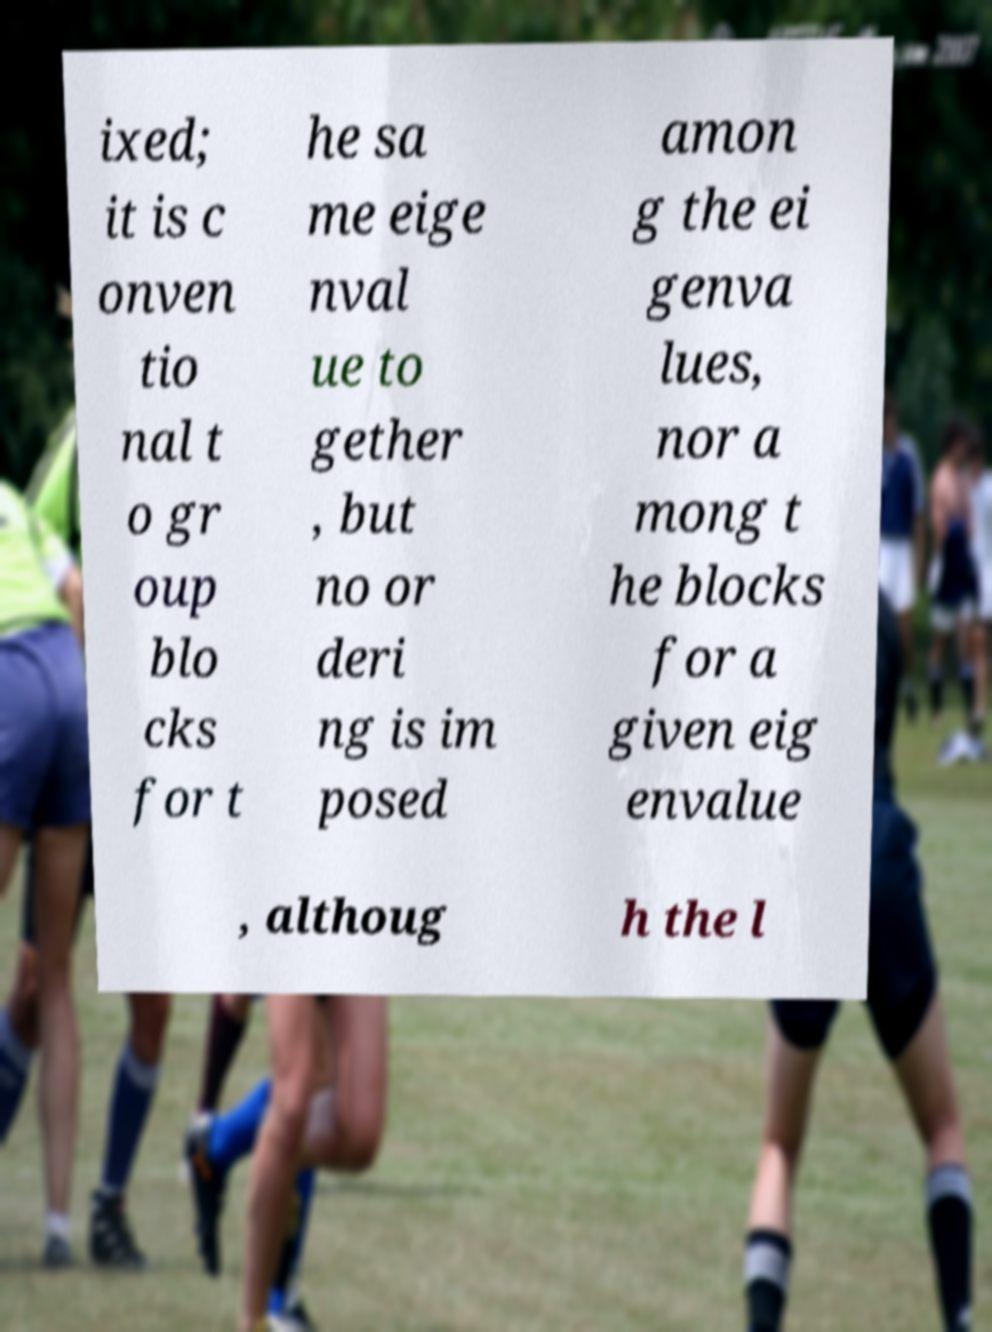Can you accurately transcribe the text from the provided image for me? ixed; it is c onven tio nal t o gr oup blo cks for t he sa me eige nval ue to gether , but no or deri ng is im posed amon g the ei genva lues, nor a mong t he blocks for a given eig envalue , althoug h the l 